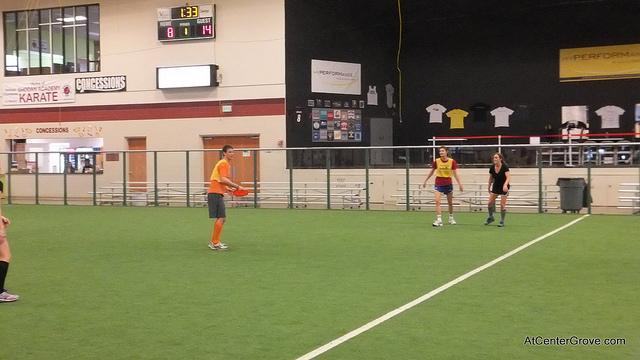How many horses are walking on the road?
Give a very brief answer. 0. 